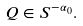<formula> <loc_0><loc_0><loc_500><loc_500>Q \in S ^ { - \alpha _ { 0 } } .</formula> 